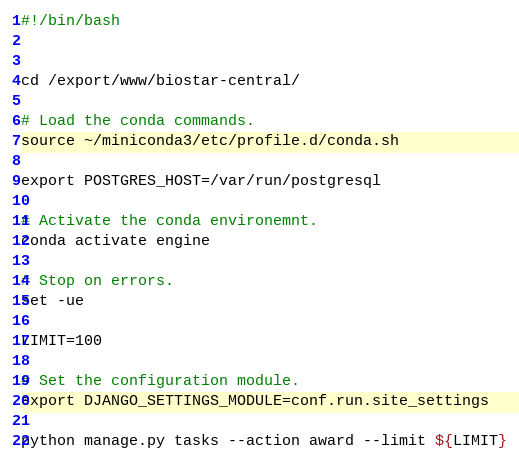<code> <loc_0><loc_0><loc_500><loc_500><_Bash_>#!/bin/bash


cd /export/www/biostar-central/

# Load the conda commands.
source ~/miniconda3/etc/profile.d/conda.sh

export POSTGRES_HOST=/var/run/postgresql

# Activate the conda environemnt.
conda activate engine

# Stop on errors.
set -ue

LIMIT=100

# Set the configuration module.
export DJANGO_SETTINGS_MODULE=conf.run.site_settings

python manage.py tasks --action award --limit ${LIMIT}</code> 